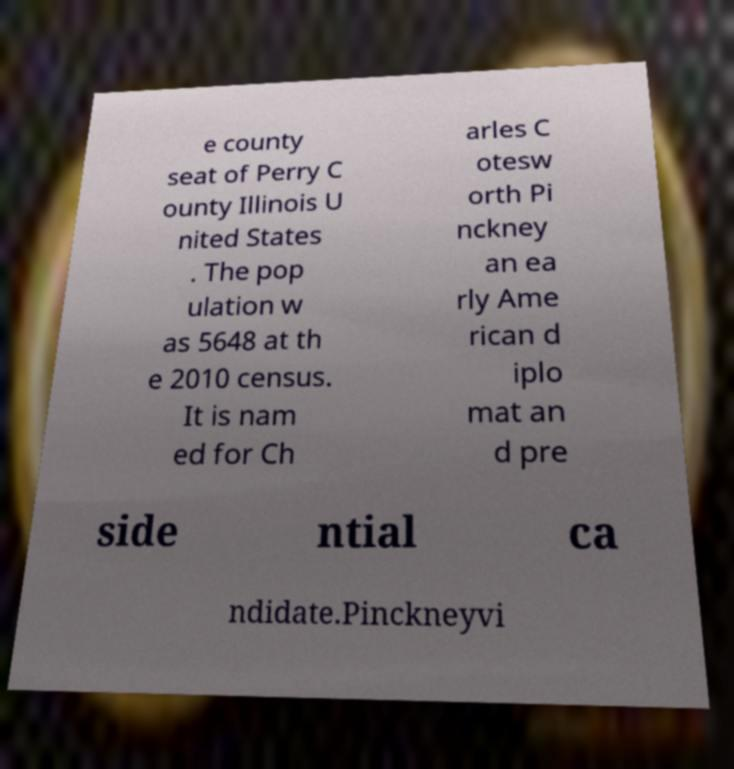Could you assist in decoding the text presented in this image and type it out clearly? e county seat of Perry C ounty Illinois U nited States . The pop ulation w as 5648 at th e 2010 census. It is nam ed for Ch arles C otesw orth Pi nckney an ea rly Ame rican d iplo mat an d pre side ntial ca ndidate.Pinckneyvi 